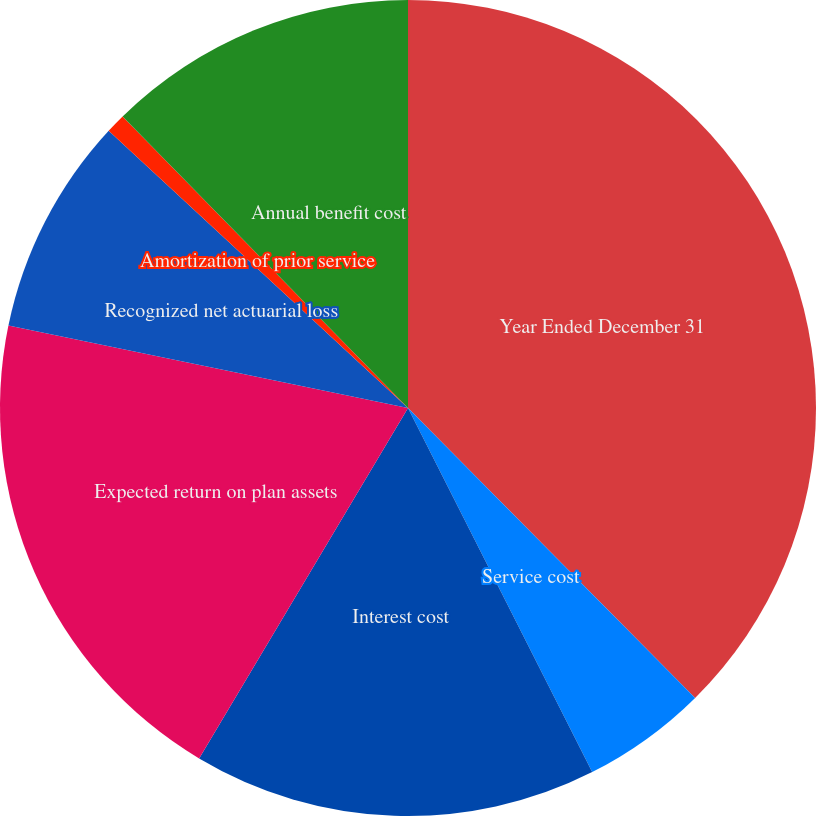<chart> <loc_0><loc_0><loc_500><loc_500><pie_chart><fcel>Year Ended December 31<fcel>Service cost<fcel>Interest cost<fcel>Expected return on plan assets<fcel>Recognized net actuarial loss<fcel>Amortization of prior service<fcel>Annual benefit cost<nl><fcel>37.58%<fcel>4.97%<fcel>16.01%<fcel>19.69%<fcel>8.65%<fcel>0.78%<fcel>12.33%<nl></chart> 